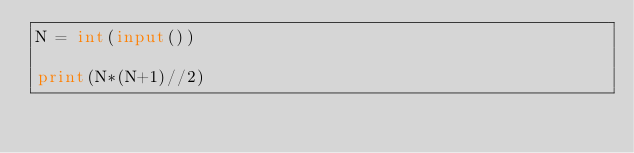<code> <loc_0><loc_0><loc_500><loc_500><_Python_>N = int(input())

print(N*(N+1)//2)</code> 